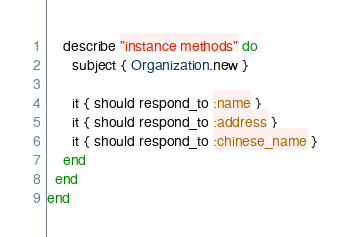<code> <loc_0><loc_0><loc_500><loc_500><_Ruby_>    describe "instance methods" do
      subject { Organization.new }

      it { should respond_to :name }
      it { should respond_to :address }
      it { should respond_to :chinese_name }
    end
  end
end
</code> 